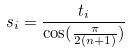<formula> <loc_0><loc_0><loc_500><loc_500>s _ { i } = \frac { t _ { i } } { \cos ( \frac { \pi } { 2 ( n + 1 ) } ) }</formula> 